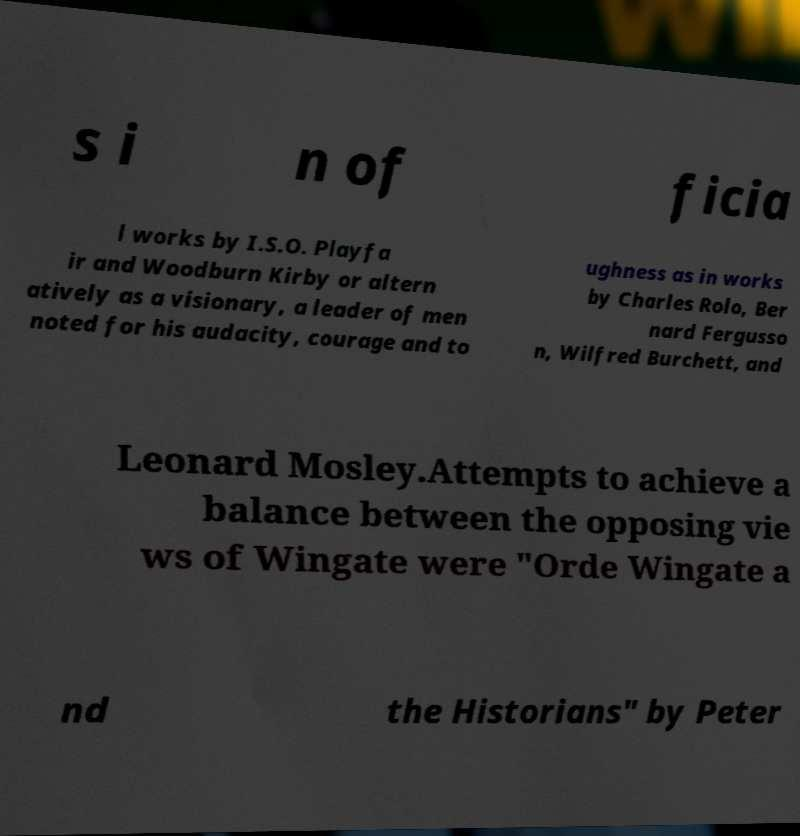For documentation purposes, I need the text within this image transcribed. Could you provide that? s i n of ficia l works by I.S.O. Playfa ir and Woodburn Kirby or altern atively as a visionary, a leader of men noted for his audacity, courage and to ughness as in works by Charles Rolo, Ber nard Fergusso n, Wilfred Burchett, and Leonard Mosley.Attempts to achieve a balance between the opposing vie ws of Wingate were "Orde Wingate a nd the Historians" by Peter 